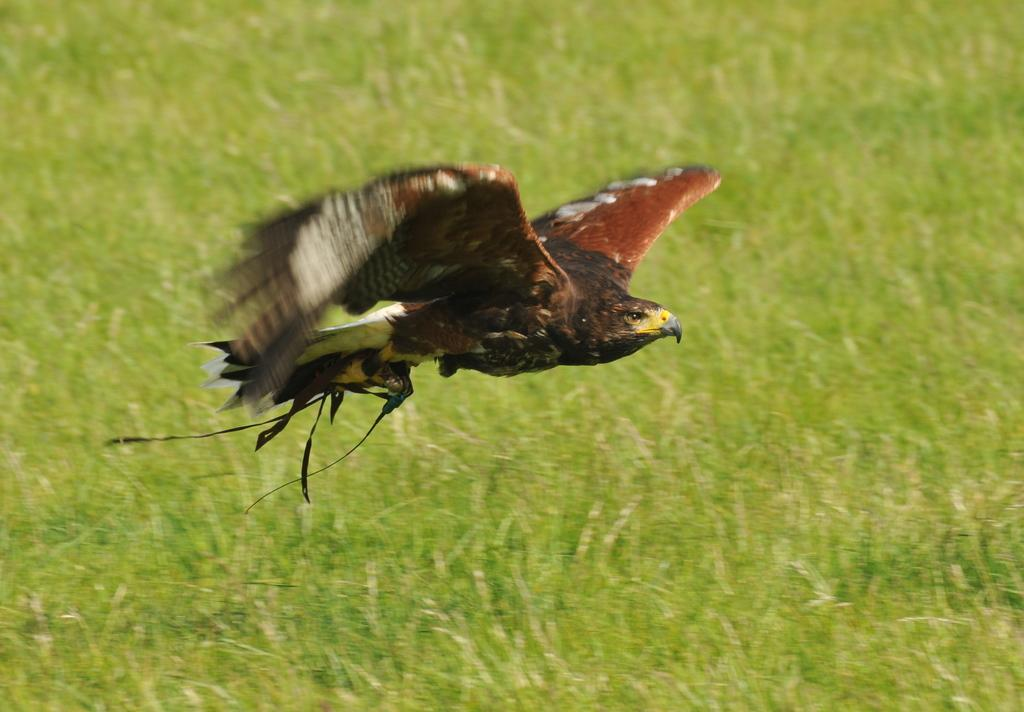What animal can be seen in the image in the image? There is a bird in the image. What is the bird doing in the image? The bird is flying in the air. What type of environment is visible in the background of the image? There is grass visible in the background of the image. What nation is the bird representing in the image? The image does not indicate any specific nation or representation; it simply shows a bird flying in the air. 